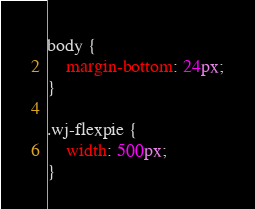<code> <loc_0><loc_0><loc_500><loc_500><_CSS_>body {
    margin-bottom: 24px;
}

.wj-flexpie {
    width: 500px;
}</code> 